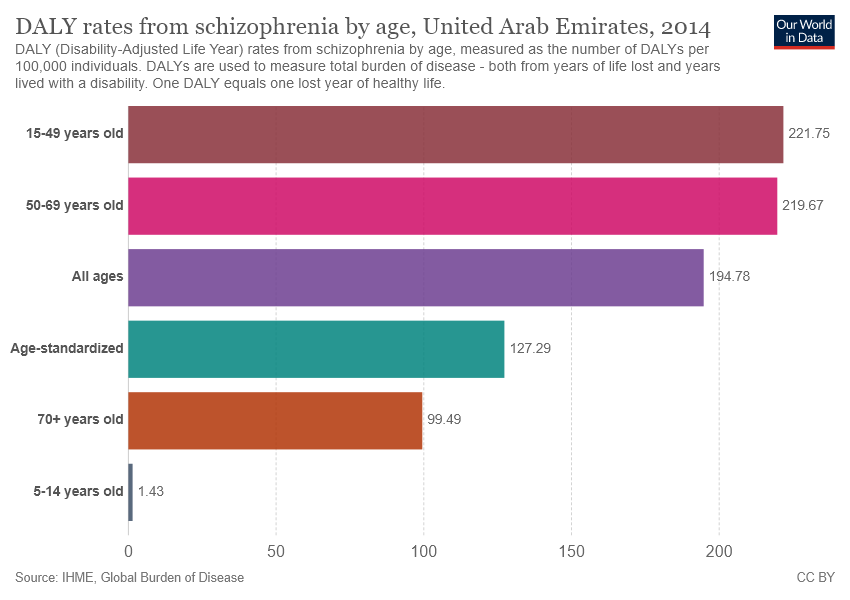Draw attention to some important aspects in this diagram. The value of pink color is different from the value of purple color by 24.89... The value of pink color is 219.67... 